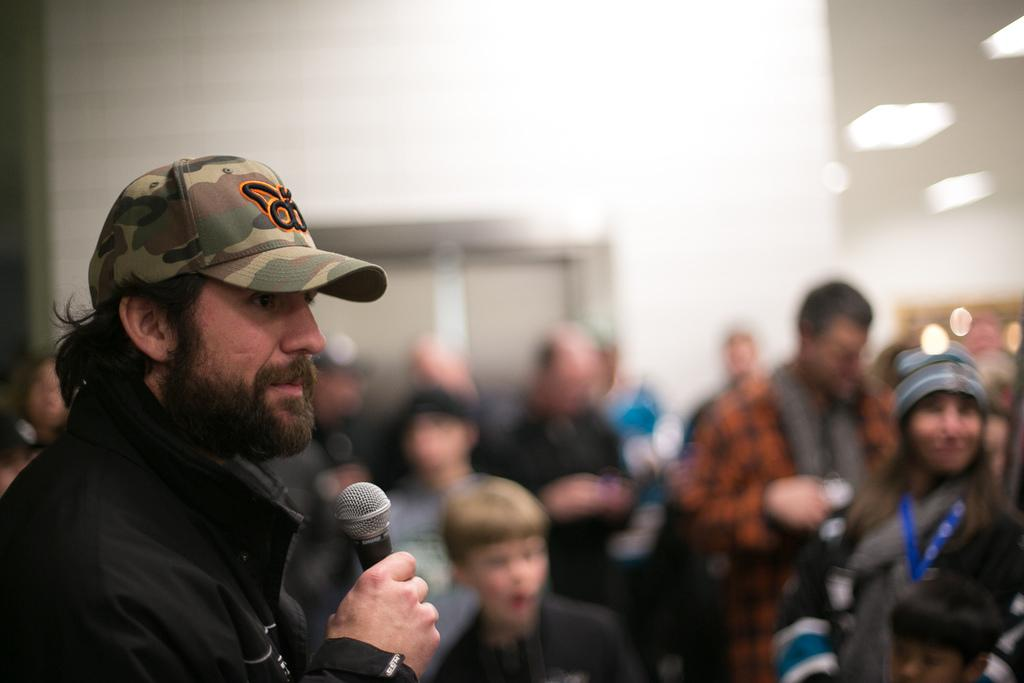What is the person on the left side of the image doing? The person is standing on the left side of the image and holding a microphone in his hand. What is the person wearing on his head? The person is wearing a cap. How many people are visible behind the person holding the microphone? There are many people standing behind the person holding the microphone. What can be seen in the background of the image? There is a white wall and a window in the background of the image. What type of fan is visible in the image? There is no fan present in the image. What books can be seen on the table next to the person holding the microphone? There is no table or books visible in the image. 